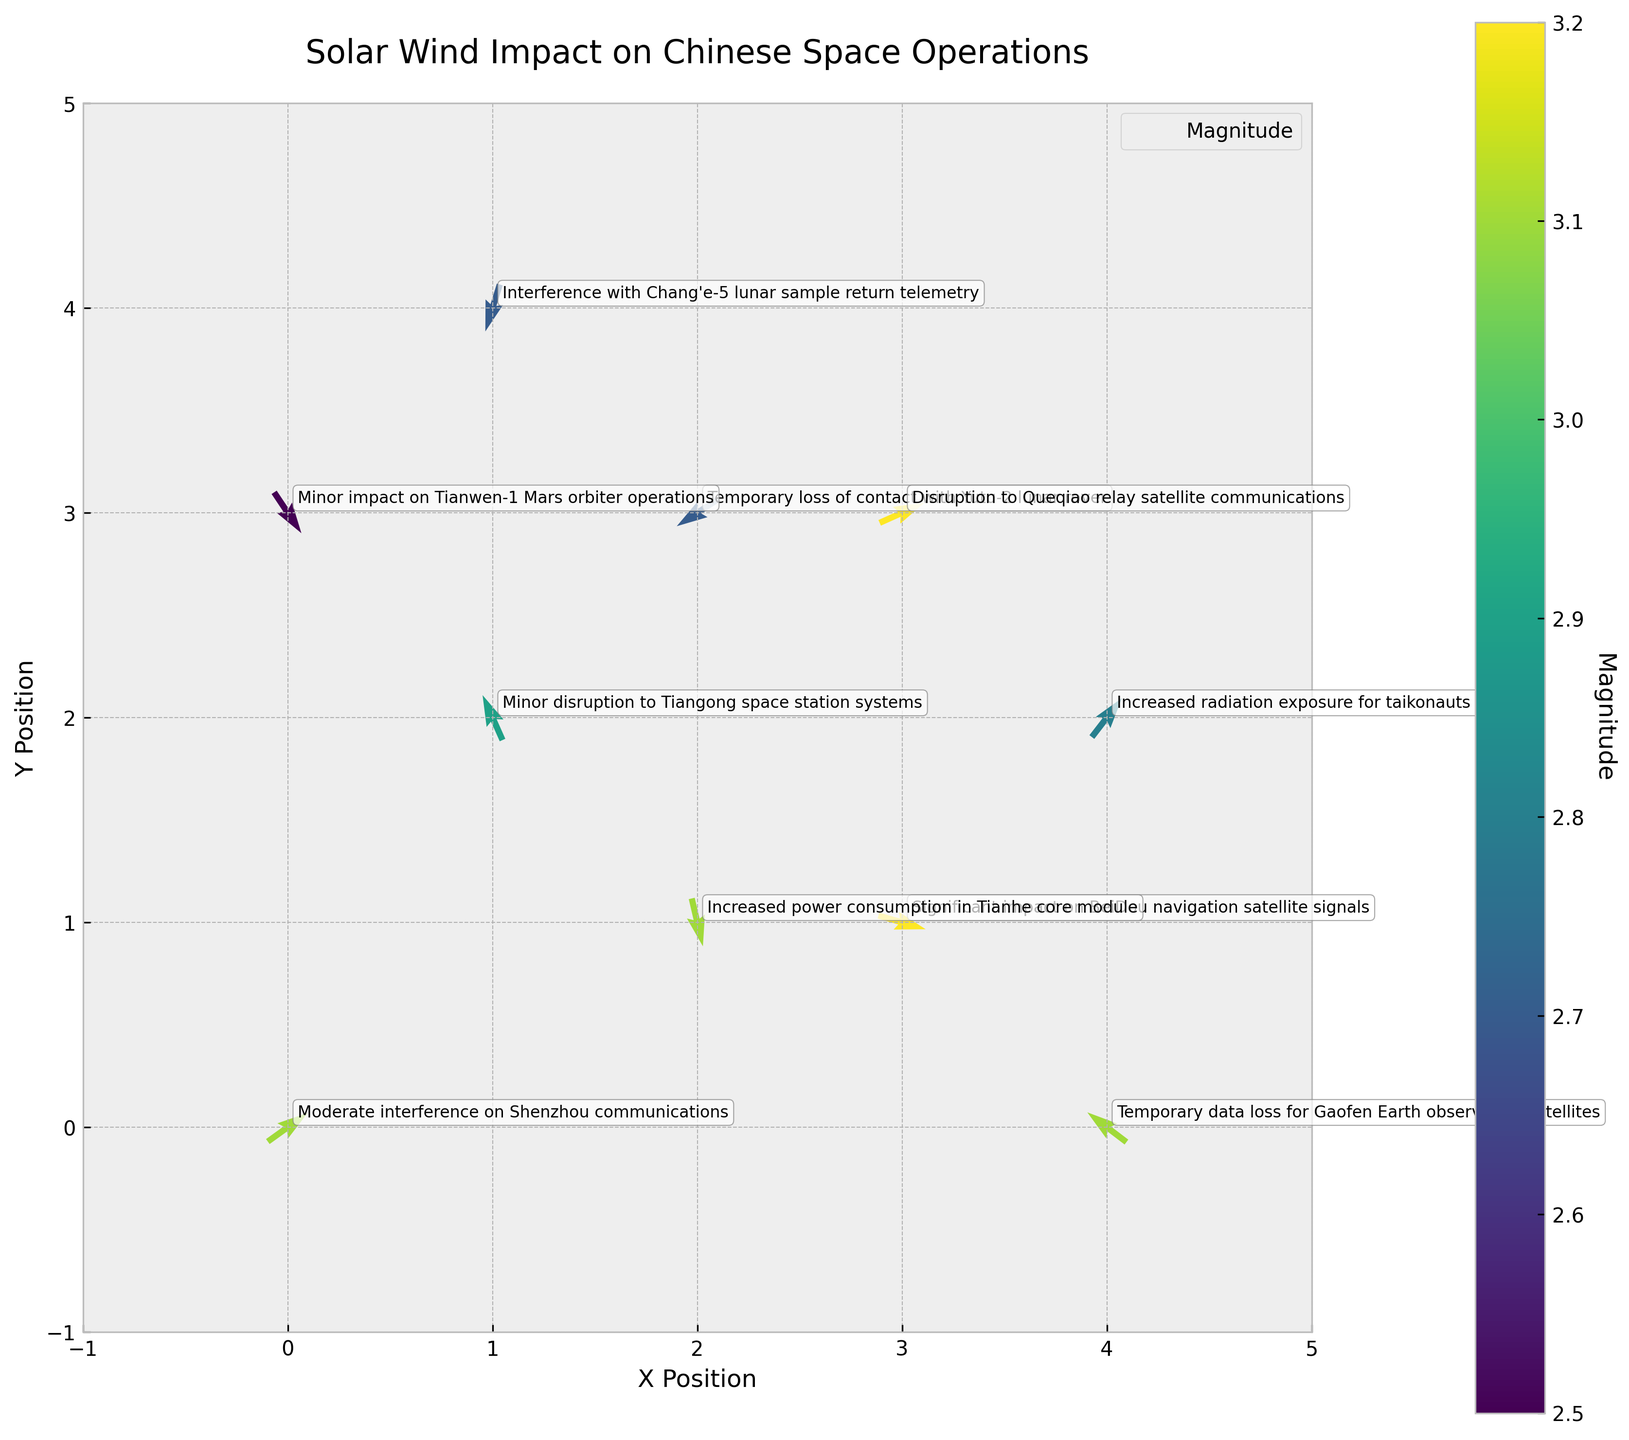What is the title of the figure? The title of the figure is written at the top in a larger font. It is there to describe the main subject of the plot.
Answer: Solar Wind Impact on Chinese Space Operations How many data points are depicted in the plot? By counting the number of quiver arrows on the plot, each represents a data point indicating both the direction and magnitude of the solar wind vector.
Answer: 10 Which event in the plot shows the highest magnitude of solar wind impact? Look at the color intensity of the arrows. The most intense color corresponds to the highest magnitude.
Answer: Disruption to Queqiao relay satellite communications and Significant impact on BeiDou navigation satellite signals Which data point indicates a 'Temporary loss of contact with Yutu-2 lunar rover'? Check the annotations corresponding to the event and locate it in the plot at its respective coordinates.
Answer: (2, 3) What is the direction of the arrow representing increased radiation exposure for taikonauts on EVA? Observe the direction of the specific quiver arrow, which shows the normalized u and v components of the vector.
Answer: North-East Which event has the smallest magnitude of solar wind impact? Identify the arrow with the least intense color and read the nearby label for the event.
Answer: Minor impact on Tianwen-1 Mars orbiter operations How does the impact on Gaofen Earth observation satellites differ from that on the Chang'e-5 lunar sample return telemetry? Compare the annotations and colors representing these two events to understand the severity and nature of impacts.
Answer: Gaofen faces temporary data loss; Chang'e-5 experiences interference What is the average magnitude of solar wind impact for all events? Add all the magnitudes together and divide by the number of data points: \( (3.1 + 2.9 + 3.2 + 2.7 + 2.8 + 2.7 + 3.2 + 2.5 + 3.1 + 3.1)/10 = 2.93 \)
Answer: 2.93 Which event related to the solar wind vector has a direction pointing primarily downward? Identify the quivers pointing downward (negative y-values for the v component) and refer to their respective annotations.
Answer: Increased power consumption in Tianhe core module Compare the direction vectors of 'Minor disruption to Tiangong space station systems' and 'Interference with Chang'e-5 lunar sample return telemetry'. Which one points more towards the south? Evaluate the v component of both vectors. A more negative v implies a southern direction.
Answer: Interference with Chang'e-5 lunar sample return telemetry 